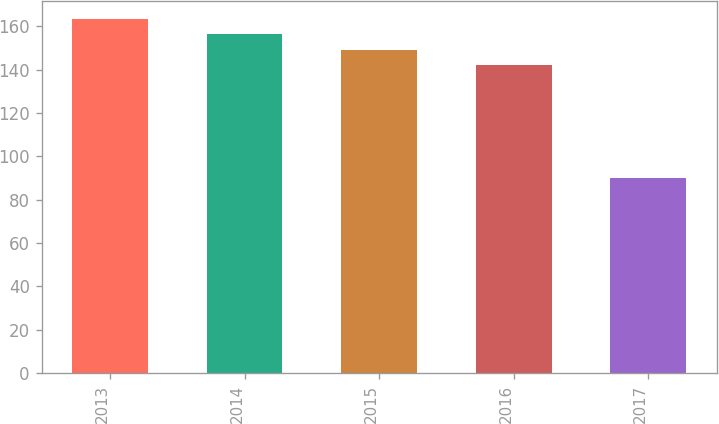<chart> <loc_0><loc_0><loc_500><loc_500><bar_chart><fcel>2013<fcel>2014<fcel>2015<fcel>2016<fcel>2017<nl><fcel>163.3<fcel>156.2<fcel>149.1<fcel>142<fcel>90<nl></chart> 